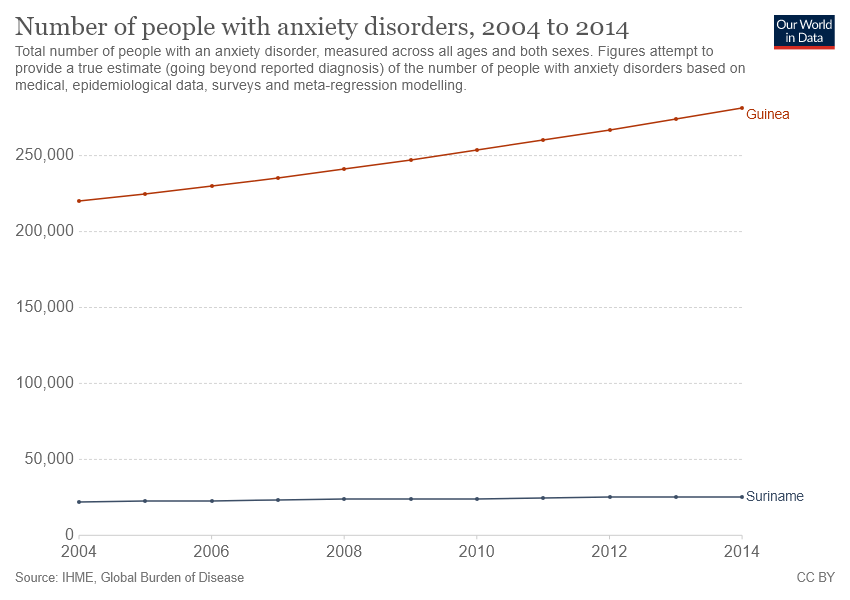Outline some significant characteristics in this image. The orange line represents the country of Guinea. The ratio between two countries in 2014 was greater than 5:1. 